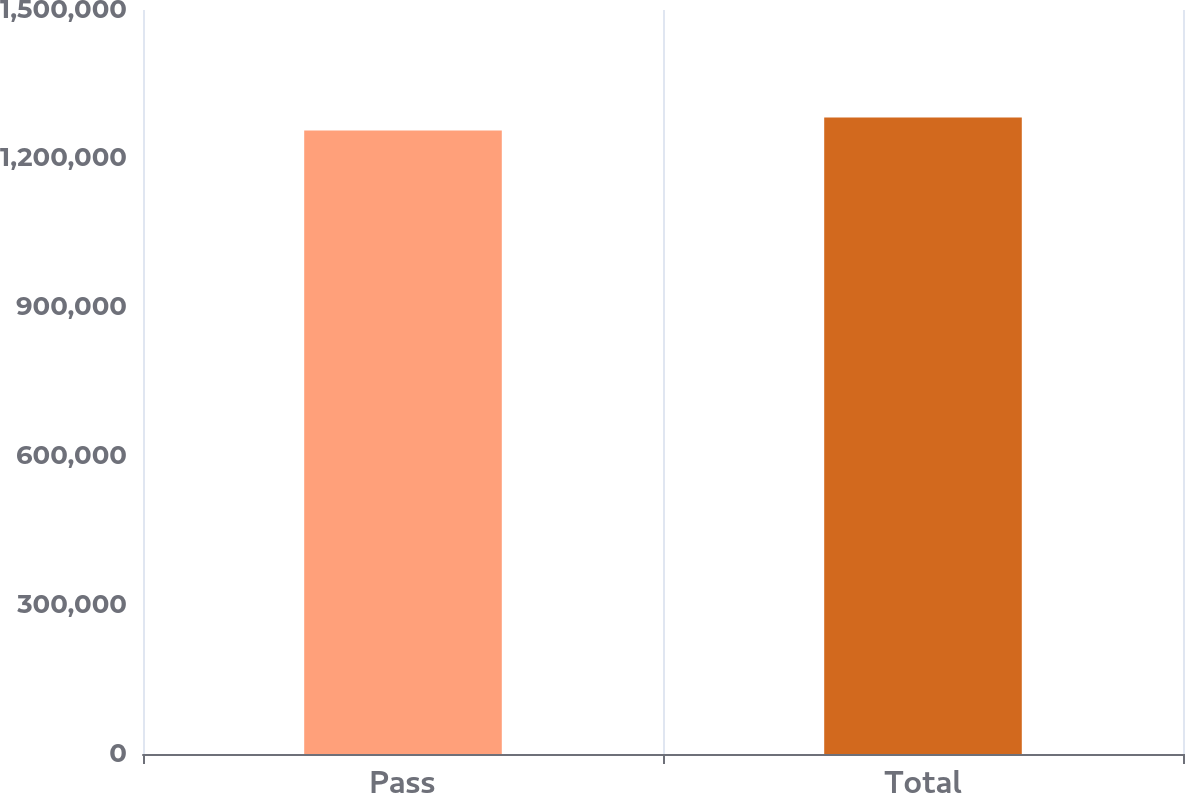<chart> <loc_0><loc_0><loc_500><loc_500><bar_chart><fcel>Pass<fcel>Total<nl><fcel>1.25713e+06<fcel>1.28305e+06<nl></chart> 